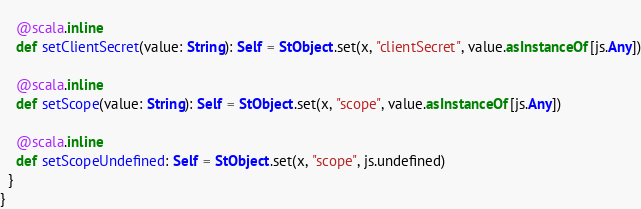<code> <loc_0><loc_0><loc_500><loc_500><_Scala_>    
    @scala.inline
    def setClientSecret(value: String): Self = StObject.set(x, "clientSecret", value.asInstanceOf[js.Any])
    
    @scala.inline
    def setScope(value: String): Self = StObject.set(x, "scope", value.asInstanceOf[js.Any])
    
    @scala.inline
    def setScopeUndefined: Self = StObject.set(x, "scope", js.undefined)
  }
}
</code> 